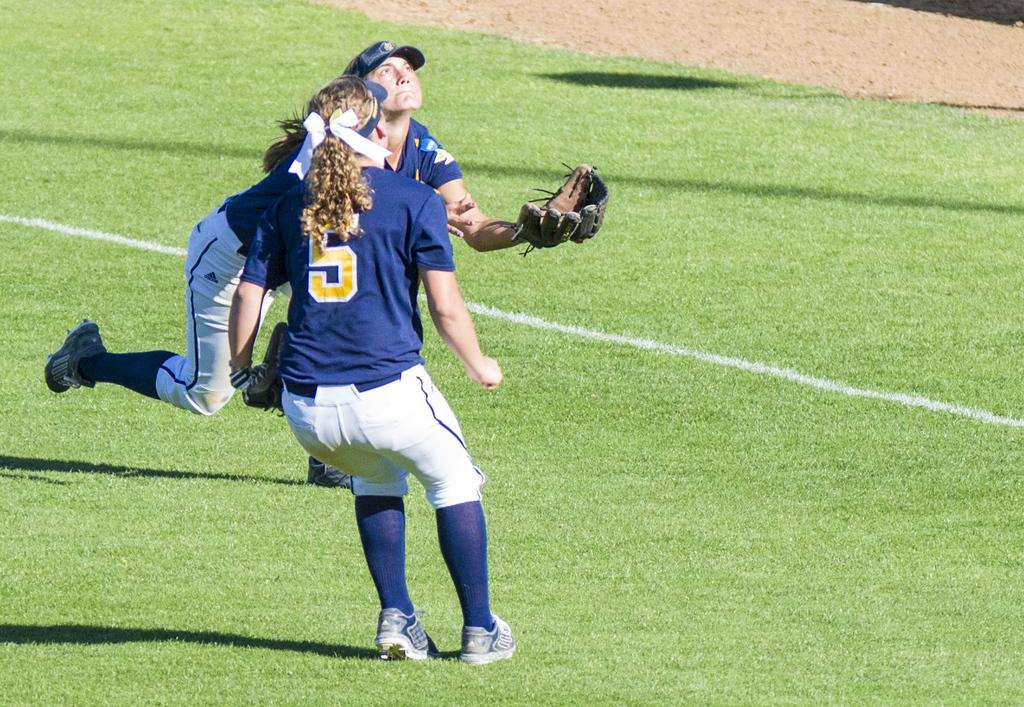What is happening in the image involving two women? One woman is standing on the ground, and the other woman is trying to catch a ball in front of her. What is the second woman wearing on her hand? The second woman is wearing a glove on her hand. What type of feeling is the ghost experiencing in the image? There is no ghost present in the image, so it is not possible to determine any feelings they might be experiencing. 